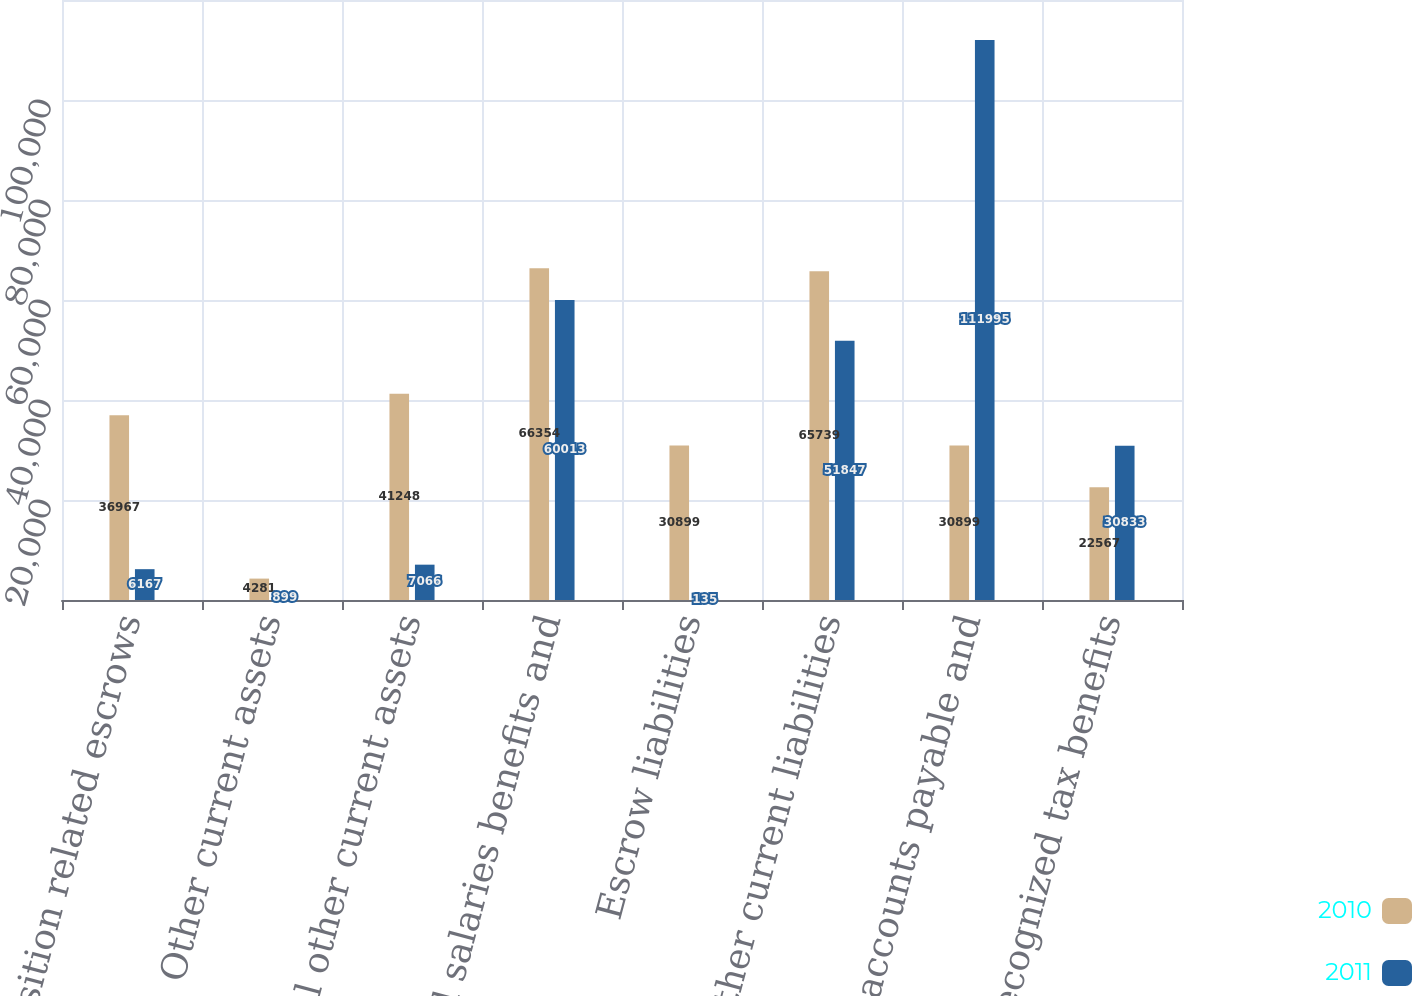Convert chart. <chart><loc_0><loc_0><loc_500><loc_500><stacked_bar_chart><ecel><fcel>Acquisition related escrows<fcel>Other current assets<fcel>Total other current assets<fcel>Accrued salaries benefits and<fcel>Escrow liabilities<fcel>Other current liabilities<fcel>Total accounts payable and<fcel>Unrecognized tax benefits<nl><fcel>2010<fcel>36967<fcel>4281<fcel>41248<fcel>66354<fcel>30899<fcel>65739<fcel>30899<fcel>22567<nl><fcel>2011<fcel>6167<fcel>899<fcel>7066<fcel>60013<fcel>135<fcel>51847<fcel>111995<fcel>30833<nl></chart> 